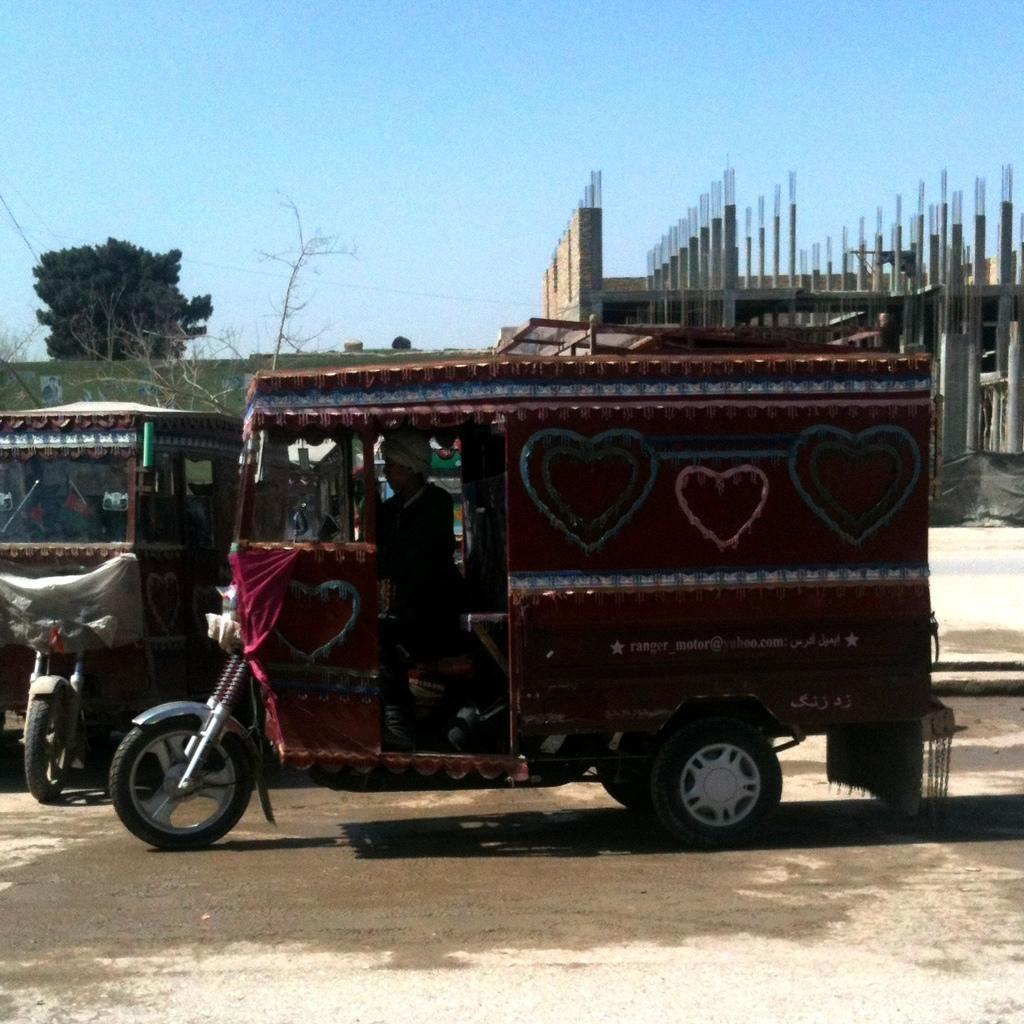What types of vehicles can be seen in the image? There are vehicles in the image, but the specific types are not mentioned. What is the primary feature of the image? The primary feature of the image is a road. Who or what else is present in the image? There are people and trees in the image. What is happening in the background of the image? There is construction of a building in the image. What can be seen above the image? The sky is visible in the image. What type of farm can be seen in the image? There is no farm present in the image. How does the construction cover the trees in the image? The construction does not cover the trees in the image; they are visible alongside the construction. 